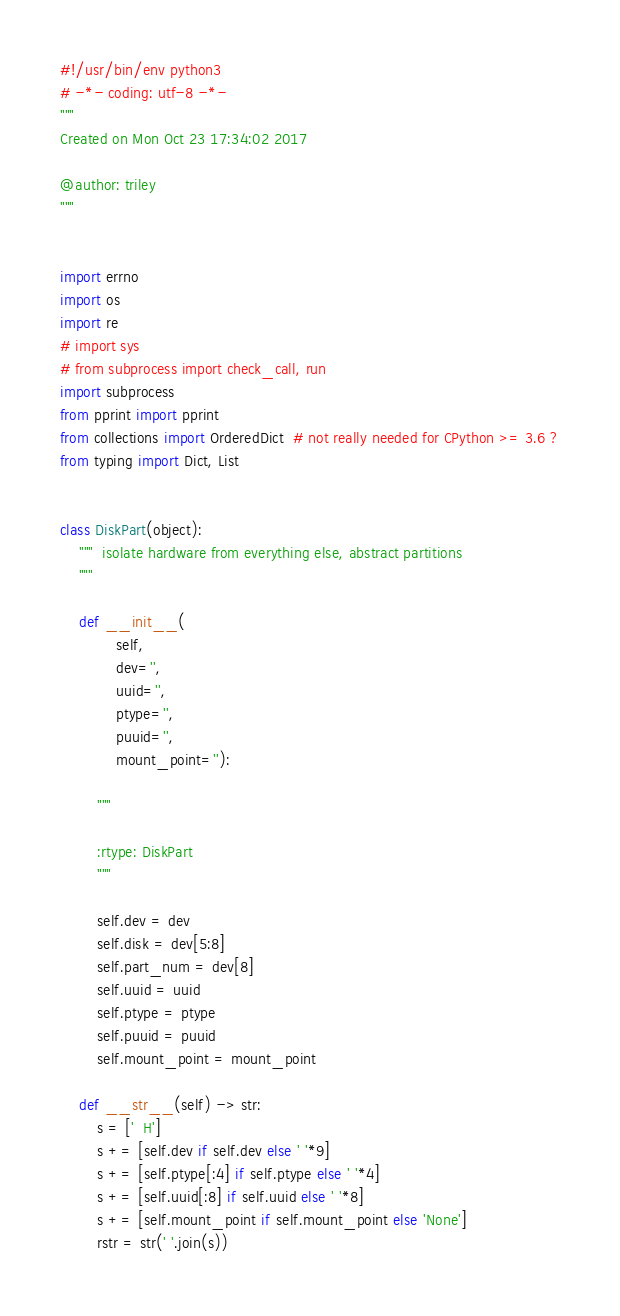<code> <loc_0><loc_0><loc_500><loc_500><_Python_>#!/usr/bin/env python3
# -*- coding: utf-8 -*-
"""
Created on Mon Oct 23 17:34:02 2017

@author: triley
"""


import errno
import os
import re
# import sys
# from subprocess import check_call, run
import subprocess
from pprint import pprint
from collections import OrderedDict  # not really needed for CPython >= 3.6 ?
from typing import Dict, List


class DiskPart(object):
    """  isolate hardware from everything else, abstract partitions
    """

    def __init__(
            self,
            dev='',
            uuid='',
            ptype='',
            puuid='',
            mount_point=''):

        """

        :rtype: DiskPart
        """

        self.dev = dev
        self.disk = dev[5:8]
        self.part_num = dev[8]
        self.uuid = uuid
        self.ptype = ptype
        self.puuid = puuid
        self.mount_point = mount_point

    def __str__(self) -> str:
        s = ['  H']
        s += [self.dev if self.dev else ' '*9]
        s += [self.ptype[:4] if self.ptype else ' '*4]
        s += [self.uuid[:8] if self.uuid else ' '*8]
        s += [self.mount_point if self.mount_point else 'None']
        rstr = str(' '.join(s))</code> 